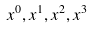Convert formula to latex. <formula><loc_0><loc_0><loc_500><loc_500>x ^ { 0 } , x ^ { 1 } , x ^ { 2 } , x ^ { 3 }</formula> 